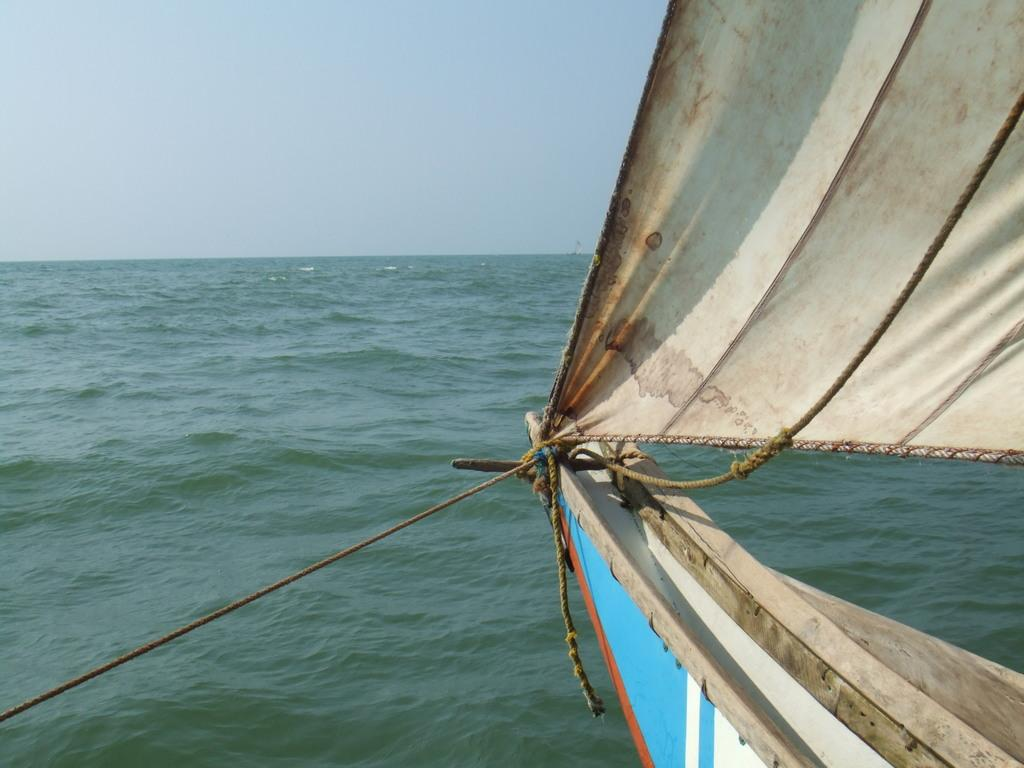What is the main subject of the image? The main subject of the image is a boat. What colors can be seen on the boat? The boat has blue, white, and brown colors. Are there any specific features on the boat? Yes, there are ropes on the boat. What can be seen in the background of the image? The background of the image includes water and the sky. What type of locket is hanging from the wire in the image? There is no locket or wire present in the image; it features a boat with ropes in a water background. 